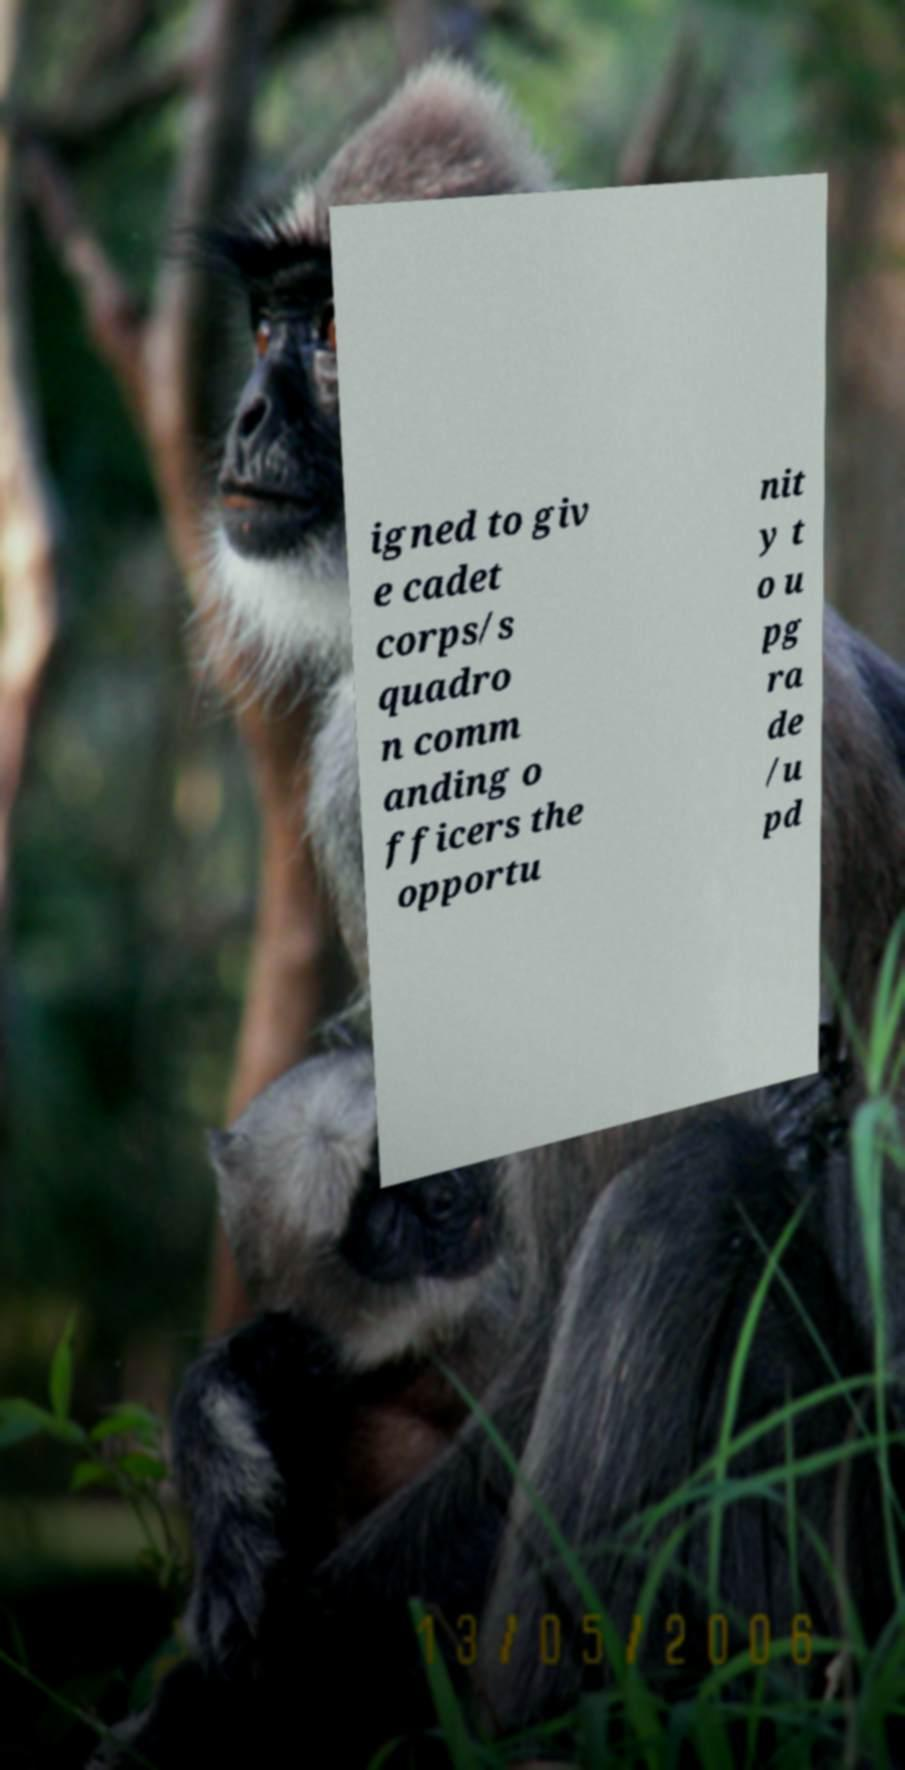For documentation purposes, I need the text within this image transcribed. Could you provide that? igned to giv e cadet corps/s quadro n comm anding o fficers the opportu nit y t o u pg ra de /u pd 